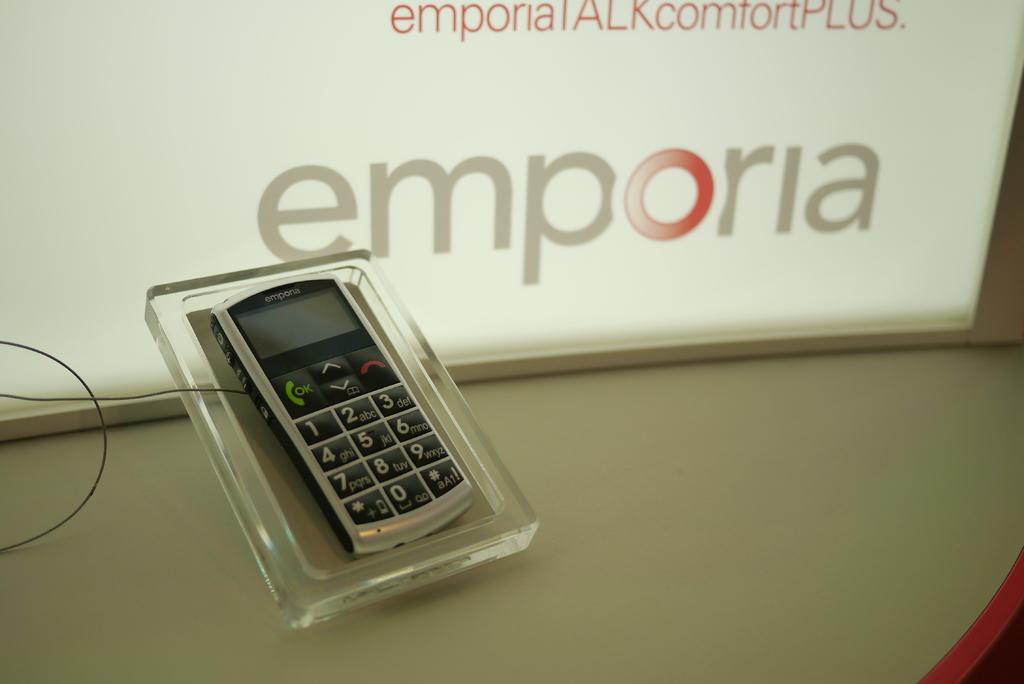What brand is shown?
Offer a very short reply. Emporia. 